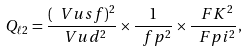Convert formula to latex. <formula><loc_0><loc_0><loc_500><loc_500>Q _ { \ell 2 } = \frac { ( \ V u s f ) ^ { 2 } } { \ V u d ^ { 2 } } \times \frac { 1 } { \ f p ^ { 2 } } \times \frac { \ F K ^ { 2 } } { \ F p i ^ { 2 } } ,</formula> 